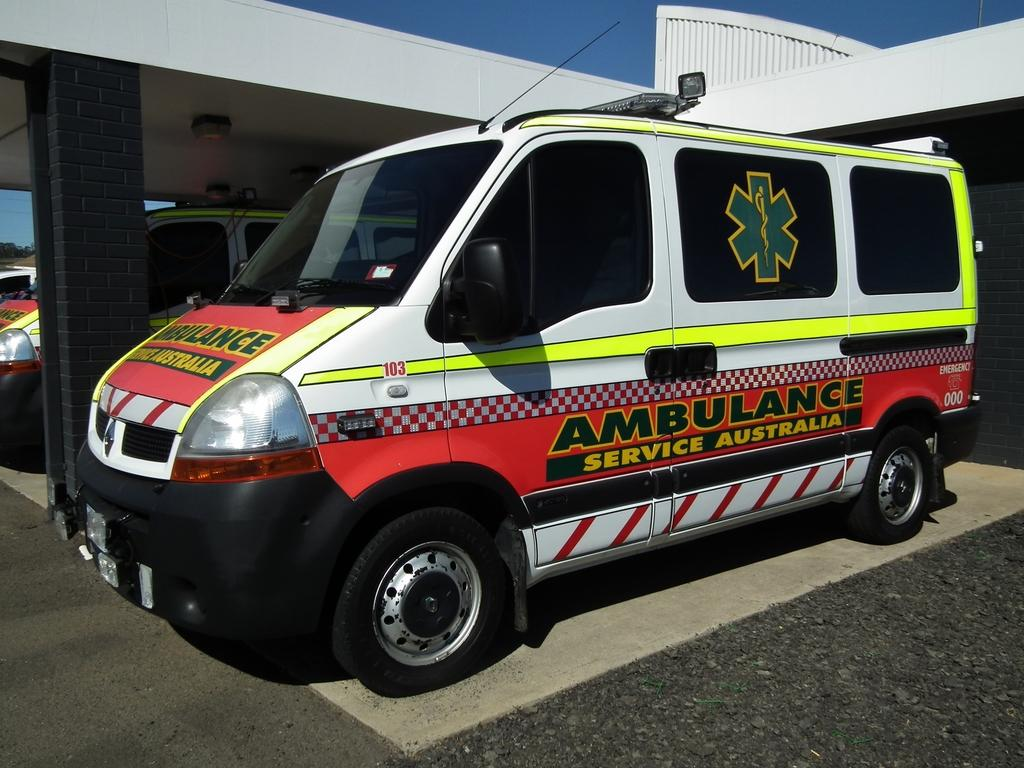<image>
Relay a brief, clear account of the picture shown. an ambulance in australia is white with red and yellow markings on it 